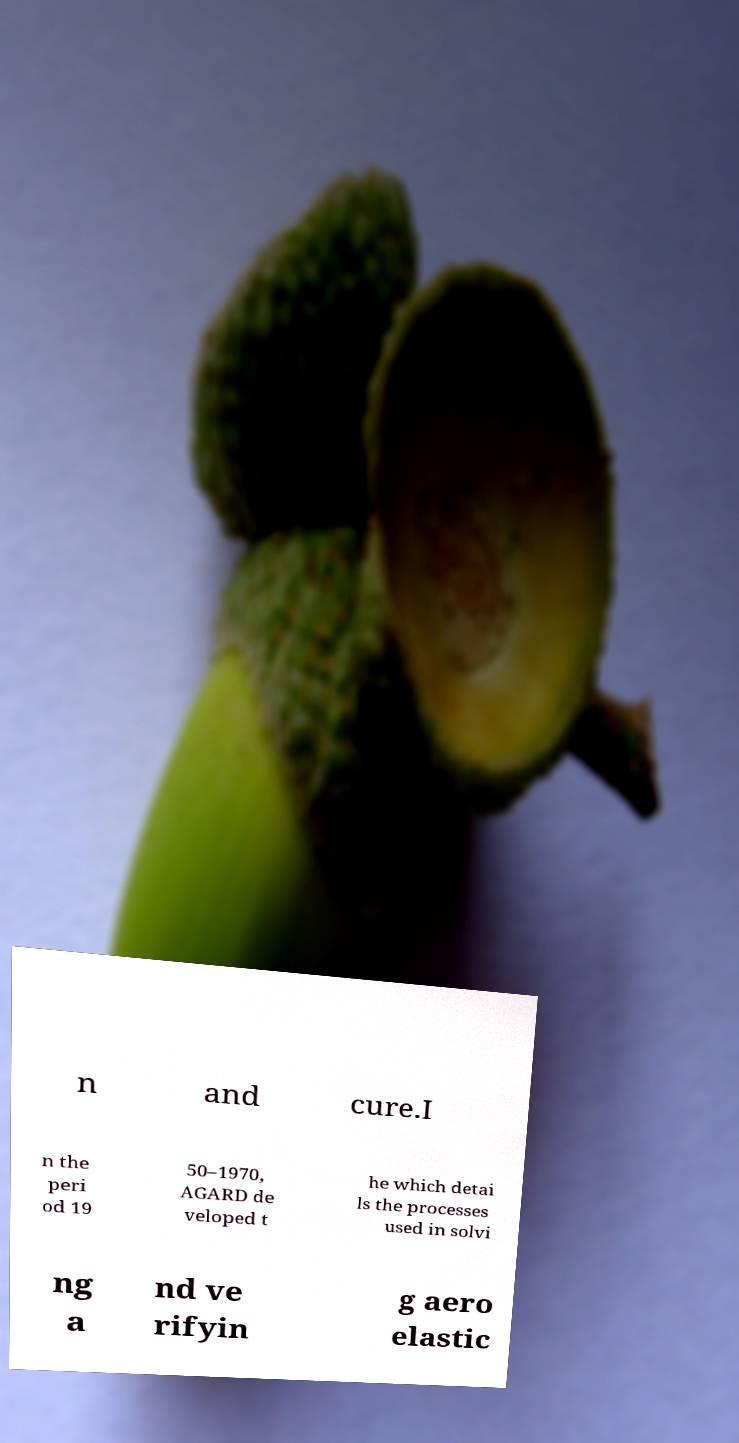Could you assist in decoding the text presented in this image and type it out clearly? n and cure.I n the peri od 19 50–1970, AGARD de veloped t he which detai ls the processes used in solvi ng a nd ve rifyin g aero elastic 